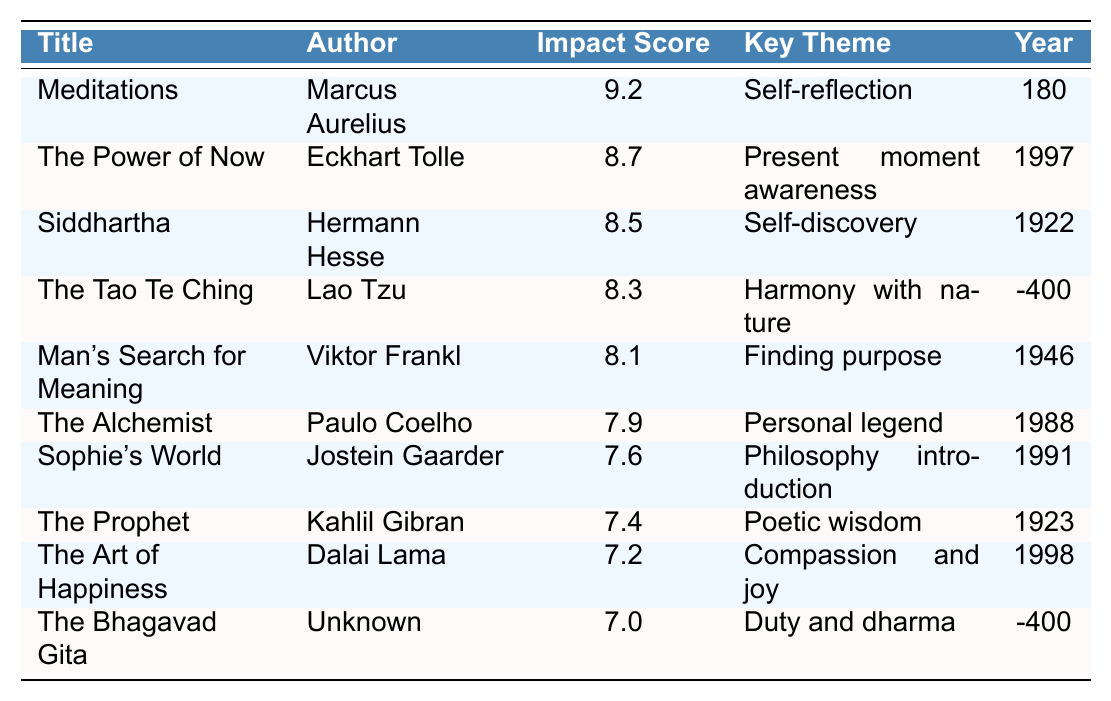What is the title of the text with the highest impact score? The table shows that "Meditations" by Marcus Aurelius has the highest impact score of 9.2.
Answer: Meditations Which author wrote "The Power of Now"? The author listed next to "The Power of Now" is Eckhart Tolle.
Answer: Eckhart Tolle What is the key theme of "Siddhartha"? The key theme for "Siddhartha" is self-discovery as indicated in the table.
Answer: Self-discovery How many texts were published before the year 1900? By reviewing the publication years, the texts published before 1900 are "The Tao Te Ching" (-400), "Siddhartha" (1922), and "The Bhagavad Gita" (-400). That's three texts.
Answer: 3 Is the impact score of "The Alchemist" higher than 8? The impact score for "The Alchemist" is 7.9, which is not greater than 8. Hence, the statement is false.
Answer: No What is the average impact score of the philosophical texts listed? To find the average: First, sum up all the impact scores: 9.2 + 8.7 + 8.5 + 8.3 + 8.1 + 7.9 + 7.6 + 7.4 + 7.2 + 7.0 = 78.9. Then divide by the number of texts (10): 78.9 / 10 = 7.89.
Answer: 7.89 Which text focuses on the theme of compassion and joy? The table specifies that "The Art of Happiness" by the Dalai Lama is focused on the theme of compassion and joy.
Answer: The Art of Happiness What is the difference in impact score between "Meditations" and "The Art of Happiness"? The impact score for "Meditations" is 9.2 and for "The Art of Happiness" is 7.2. The difference is 9.2 - 7.2 = 2.0.
Answer: 2.0 What is the key theme of "The Bhagavad Gita"? The key theme mentioned for "The Bhagavad Gita" is duty and dharma according to the table.
Answer: Duty and dharma If we were to rank the texts, which text would be in the 5th place based on the impact score? Based on the impact scores, the ranking is as follows: 1. Meditations, 2. The Power of Now, 3. Siddhartha, 4. The Tao Te Ching, 5. Man's Search for Meaning. The text in 5th place is "Man's Search for Meaning".
Answer: Man's Search for Meaning 